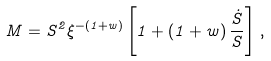<formula> <loc_0><loc_0><loc_500><loc_500>M = S ^ { 2 } \xi ^ { - ( 1 + w ) } \left [ 1 + \left ( 1 + w \right ) \frac { \dot { S } } { S } \right ] \, ,</formula> 